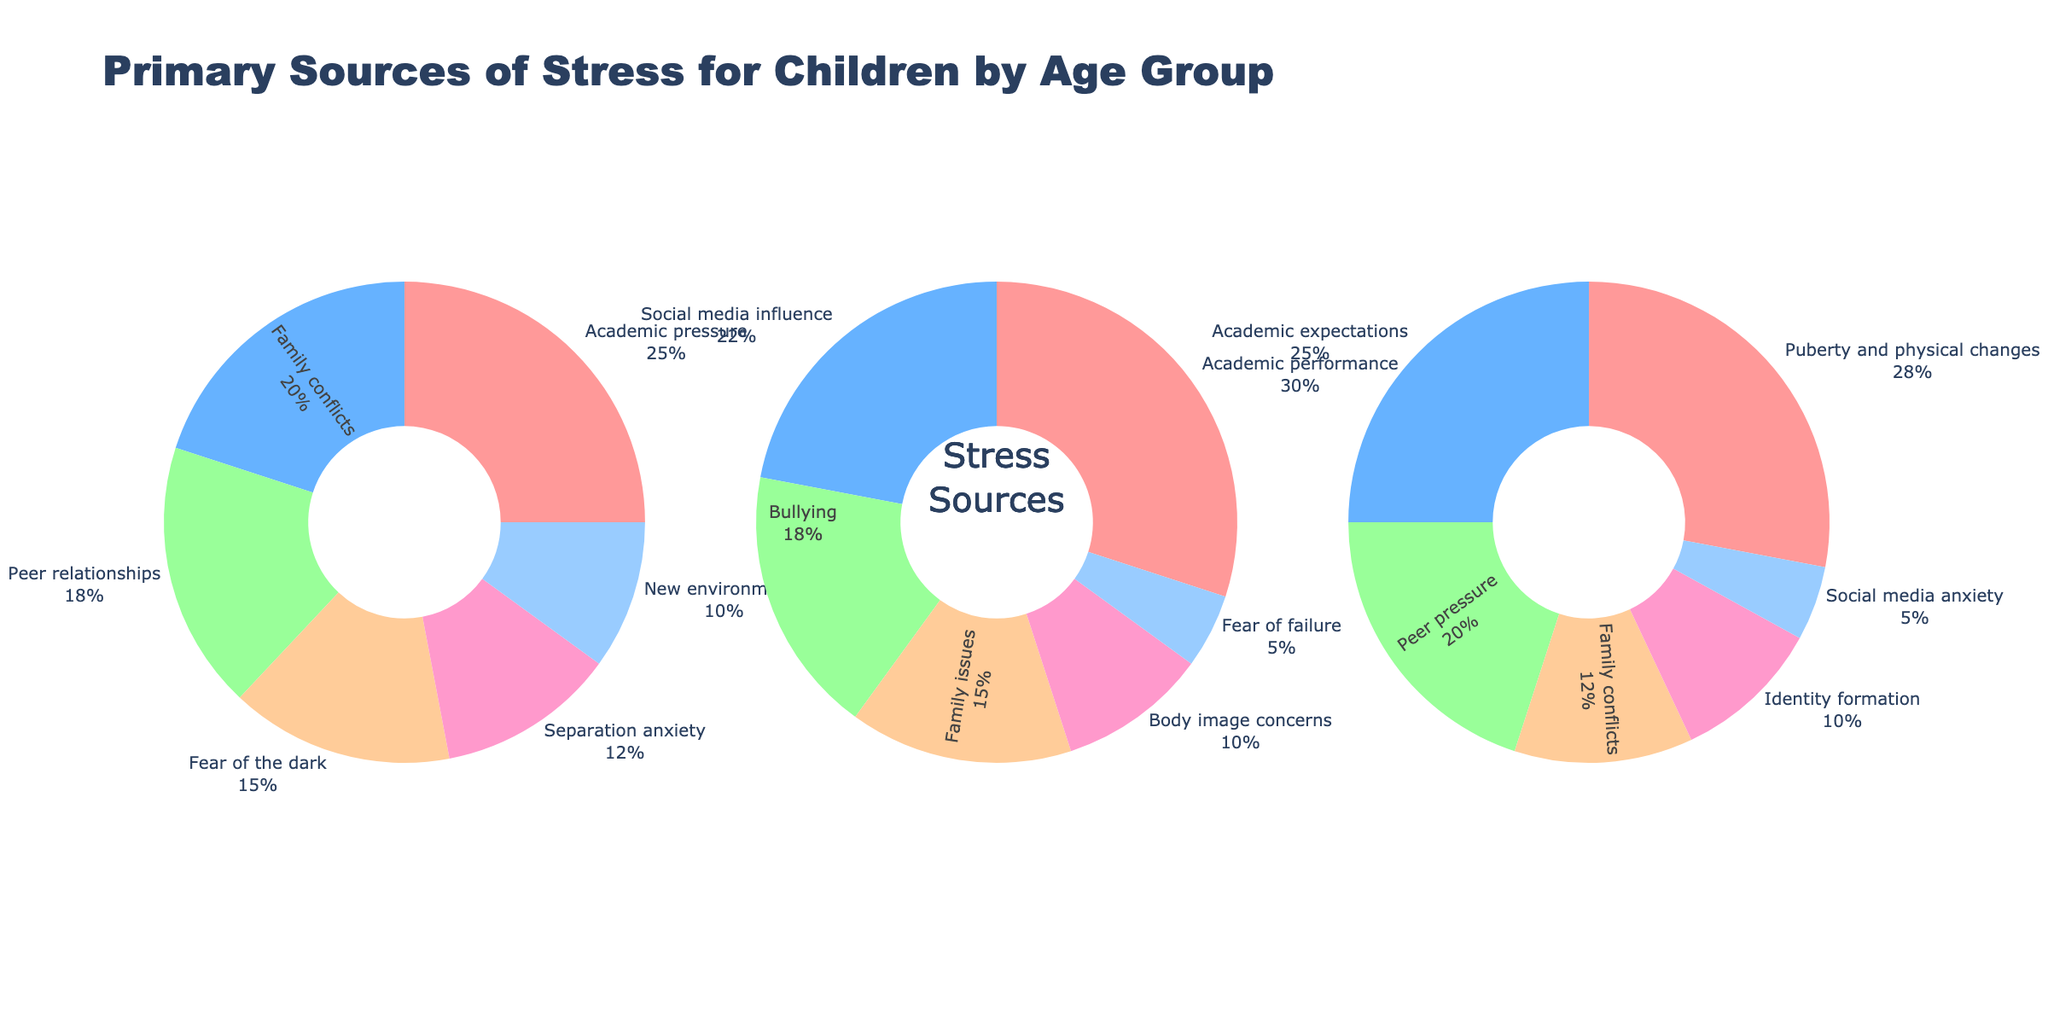Which age group has the highest percentage attributed to Academic performance-related stress? The pie chart shows three age groups: 6-8 years, 9-11 years, and 12-14 years. From these, it is evident that the 9-11 years group has the highest percentage for Academic performance stress at 30%.
Answer: 9-11 years In which age group is Family conflicts a major source of stress, and what percentage does it represent? Observing the three pie charts, Family conflicts stress features in all age groups but is most significant in the 6-8 years group at 20%.
Answer: 6-8 years, 20% What is the combined percentage of stress sources for Academic-related stress across all age groups? For each age group, sum the percentages for Academic pressure and Academic performance: 25% (6-8 years) + 30% (9-11 years) + 25% (12-14 years) = 80%.
Answer: 80% Which source of stress is unique to the 12-14 years age group, not seen in other age groups? Reviewing each pie chart, Puberty and physical changes (28%) appears as a stress source only in the 12-14 years group.
Answer: Puberty and physical changes Among the sources of stress in the 6-8 years group, which is the least significant and what percentage does it have? In the pie chart for 6-8 years, New environments is the smallest segment, representing 10%.
Answer: New environments, 10% Compare the percentage of stress due to Peer relationships in the 6-8 years group versus Peer pressure in the 12-14 years group. Who is more stressed? The 6-8 years group has 18% stress due to Peer relationships, while the 12-14 years group has 20% stress due to Peer pressure. Hence, Peer pressure in the 12-14 years group is higher.
Answer: 12-14 years What is the total percentage of stress sources related to peers (Peer relationships/pressure) and body image concerns in the 9-11 years age group? For the 9-11 years group, Peer relationships/pressure isn't listed but Body image concerns is at 10%. Peer influence through Social media is 22%: 22% + 10% = 32%.
Answer: 32% How does the percentage for Bullying in the 9-11 years group compare to the percentage for Separation anxiety in the 6-8 years group? From their respective charts, Bullying in the 9-11 years group is 18% and Separation anxiety in the 6-8 years group is 12%.
Answer: Bullying is higher Is there a stress source related to family that has a decreasing trend as age increases? Observe the percentages in each group: Family conflicts for 6-8 years is 20%, Family issues for 9-11 years is 15%, and Family conflicts in 12-14 years is 12%. This indicates a decreasing trend.
Answer: Yes, Family conflicts/issues 